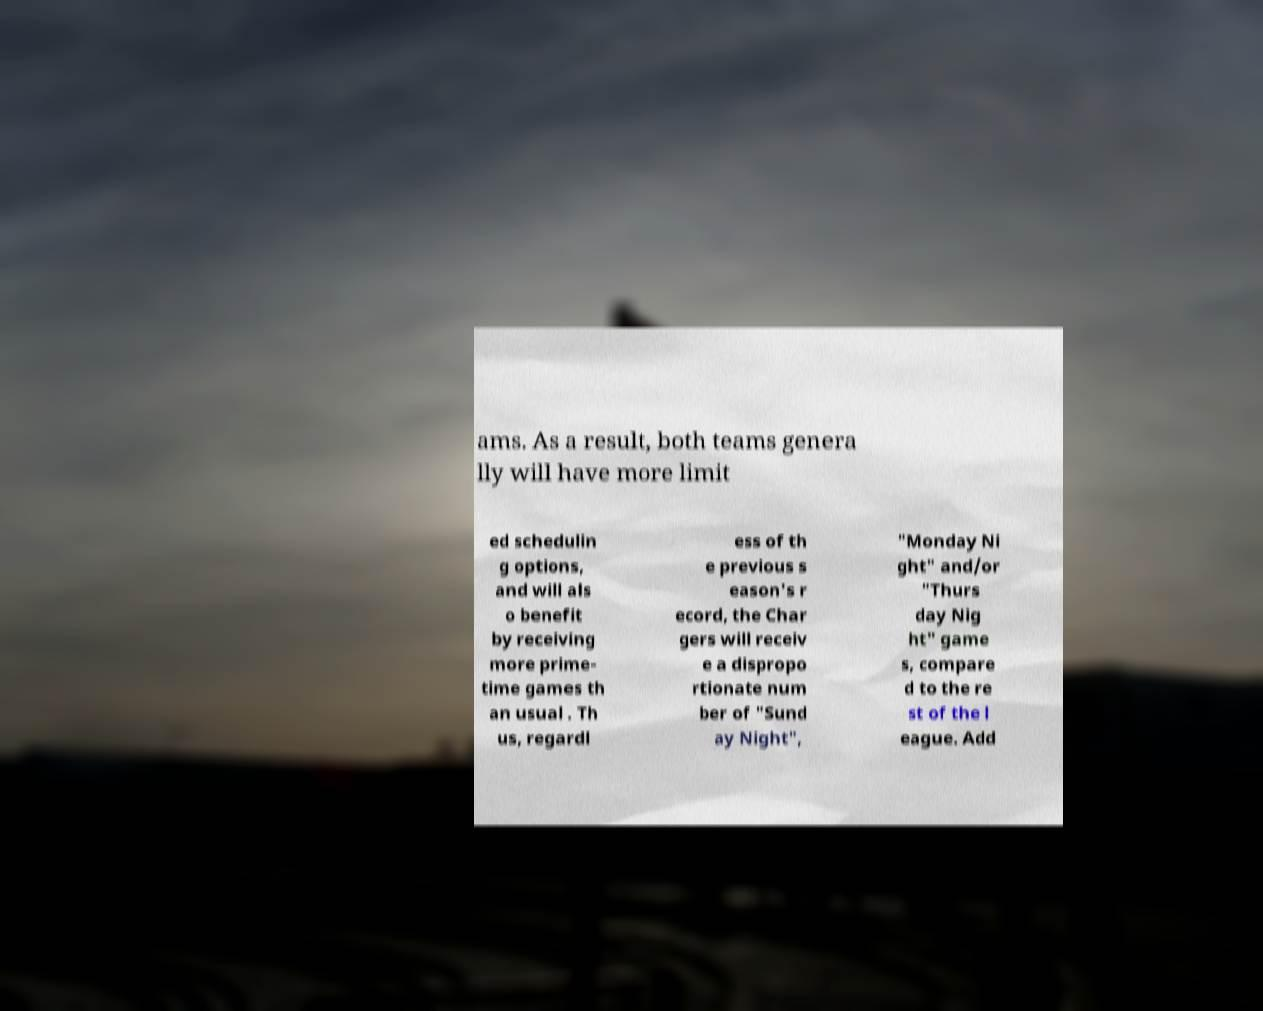For documentation purposes, I need the text within this image transcribed. Could you provide that? ams. As a result, both teams genera lly will have more limit ed schedulin g options, and will als o benefit by receiving more prime- time games th an usual . Th us, regardl ess of th e previous s eason's r ecord, the Char gers will receiv e a dispropo rtionate num ber of "Sund ay Night", "Monday Ni ght" and/or "Thurs day Nig ht" game s, compare d to the re st of the l eague. Add 